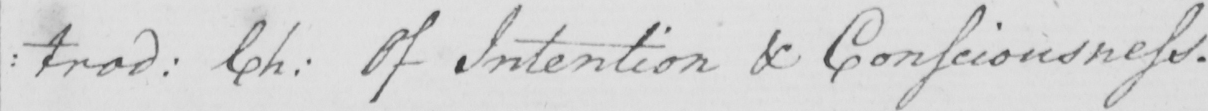Can you read and transcribe this handwriting? : trod :  Ch :  Of Intention & Consciousness . 